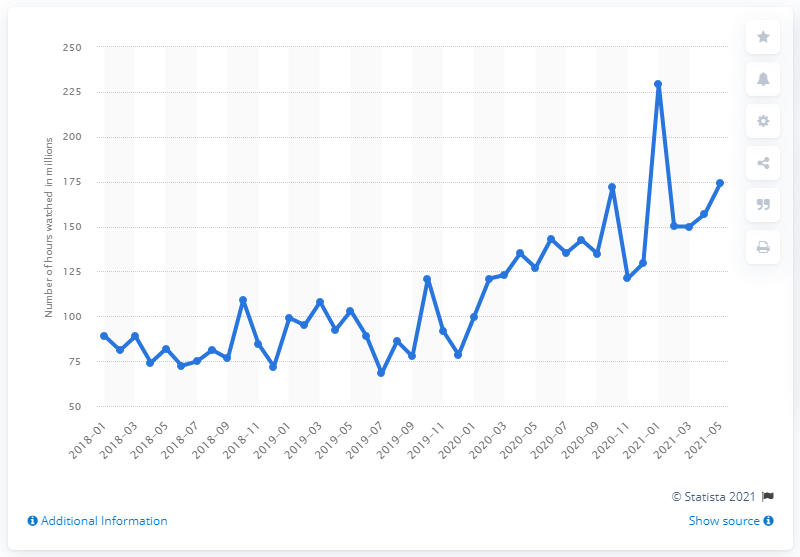Point out several critical features in this image. In May 2021, a total of 174 hours were watched on Twitch. 